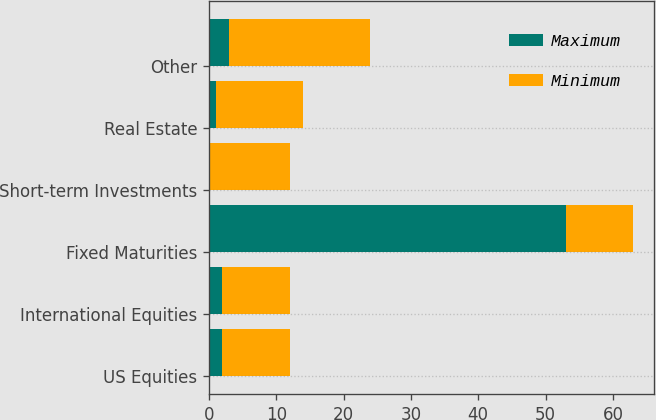<chart> <loc_0><loc_0><loc_500><loc_500><stacked_bar_chart><ecel><fcel>US Equities<fcel>International Equities<fcel>Fixed Maturities<fcel>Short-term Investments<fcel>Real Estate<fcel>Other<nl><fcel>Maximum<fcel>2<fcel>2<fcel>53<fcel>0<fcel>1<fcel>3<nl><fcel>Minimum<fcel>10<fcel>10<fcel>10<fcel>12<fcel>13<fcel>21<nl></chart> 